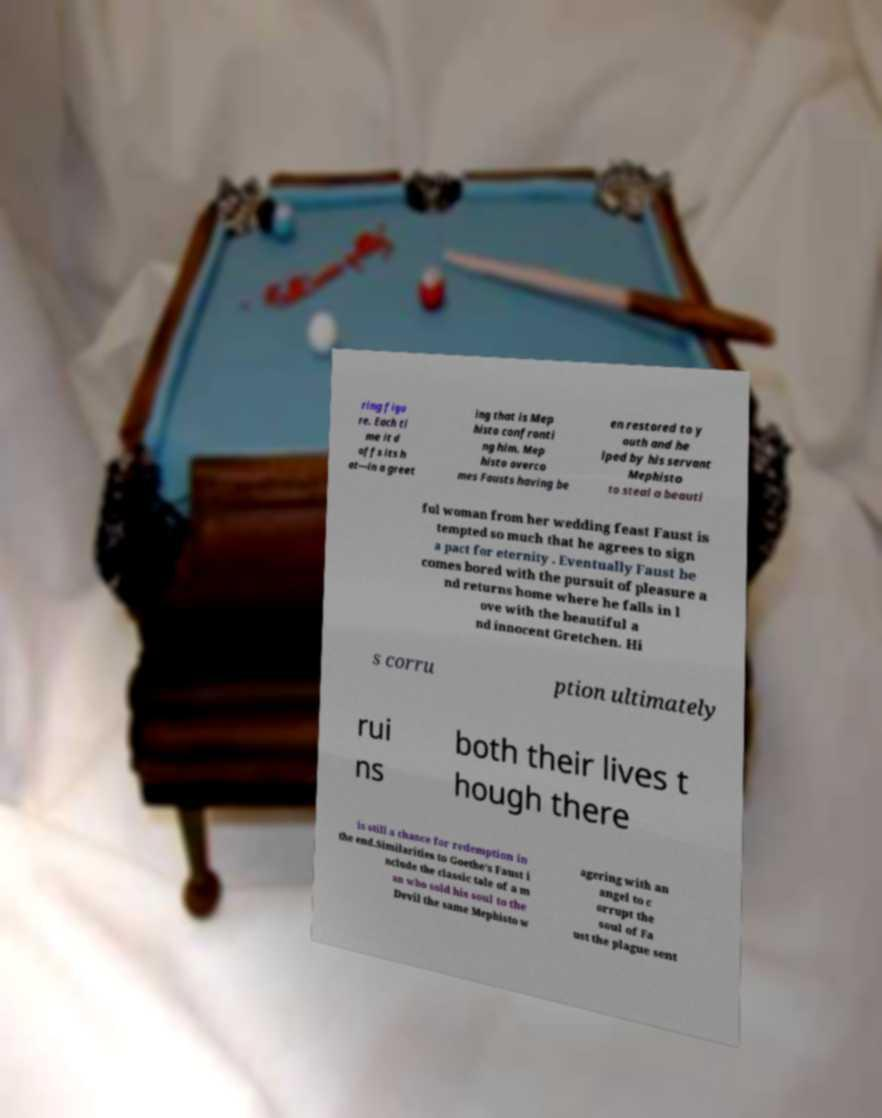Could you assist in decoding the text presented in this image and type it out clearly? ring figu re. Each ti me it d offs its h at—in a greet ing that is Mep histo confronti ng him. Mep histo overco mes Fausts having be en restored to y outh and he lped by his servant Mephisto to steal a beauti ful woman from her wedding feast Faust is tempted so much that he agrees to sign a pact for eternity . Eventually Faust be comes bored with the pursuit of pleasure a nd returns home where he falls in l ove with the beautiful a nd innocent Gretchen. Hi s corru ption ultimately rui ns both their lives t hough there is still a chance for redemption in the end.Similarities to Goethe's Faust i nclude the classic tale of a m an who sold his soul to the Devil the same Mephisto w agering with an angel to c orrupt the soul of Fa ust the plague sent 